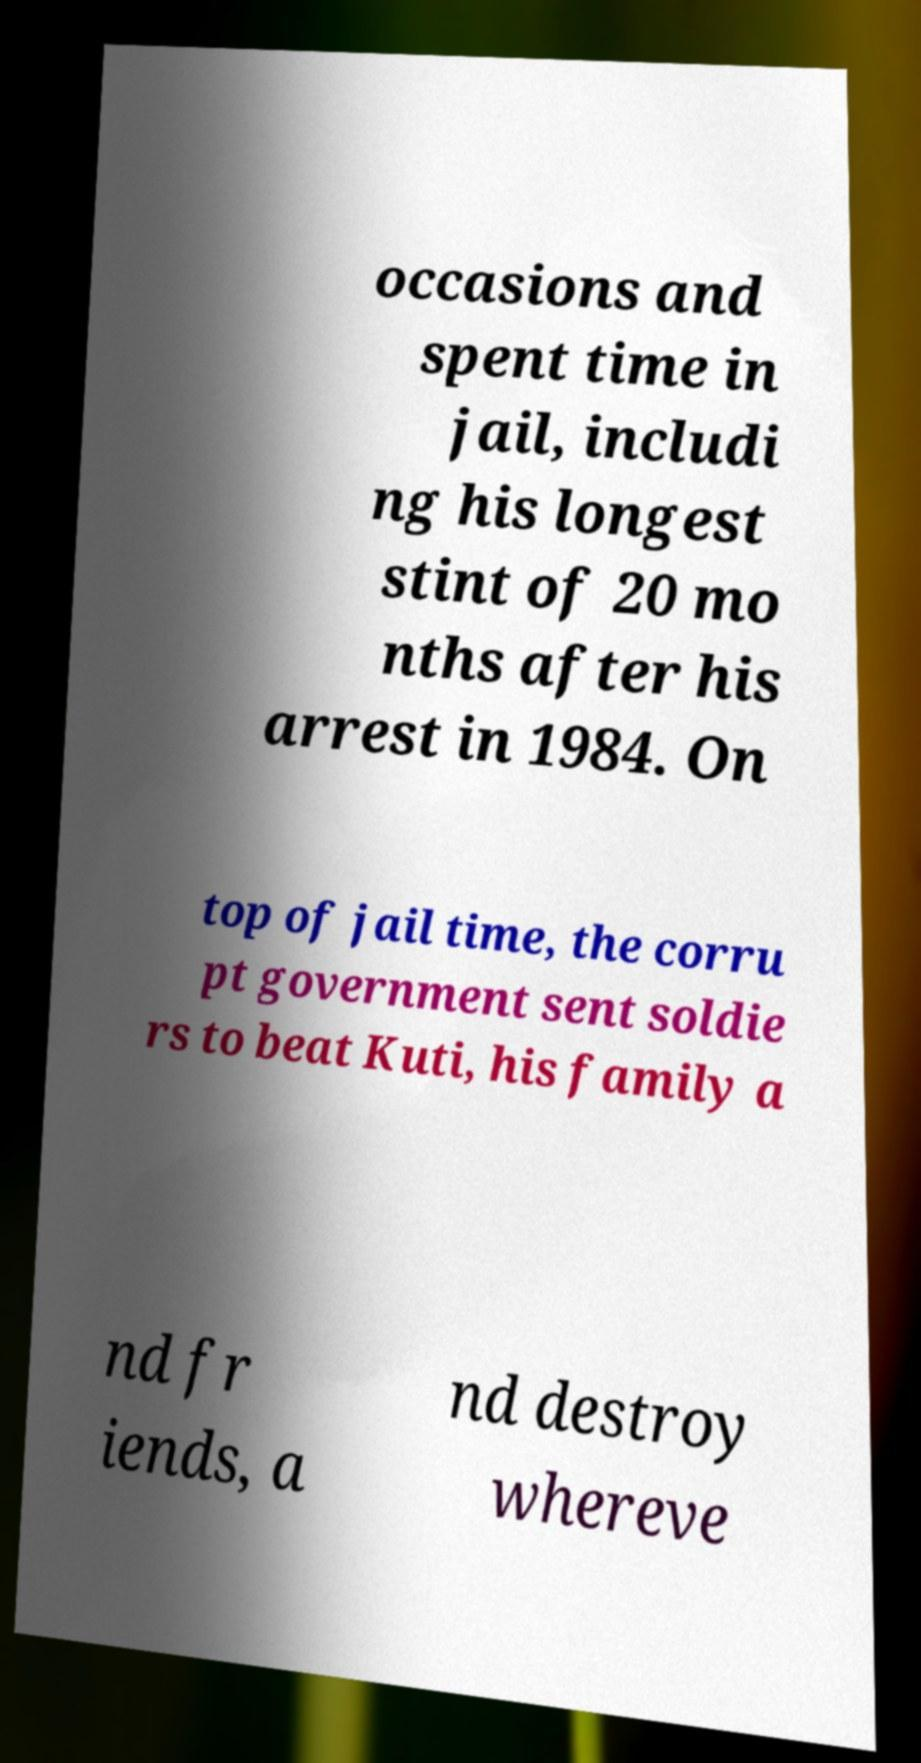For documentation purposes, I need the text within this image transcribed. Could you provide that? occasions and spent time in jail, includi ng his longest stint of 20 mo nths after his arrest in 1984. On top of jail time, the corru pt government sent soldie rs to beat Kuti, his family a nd fr iends, a nd destroy whereve 